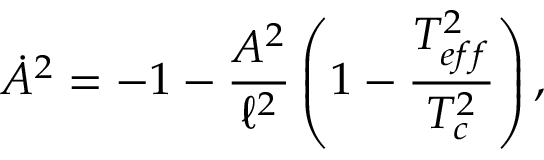<formula> <loc_0><loc_0><loc_500><loc_500>\dot { A } ^ { 2 } = - 1 - \frac { A ^ { 2 } } { \ell ^ { 2 } } \left ( 1 - \frac { T _ { e f f } ^ { 2 } } { T _ { c } ^ { 2 } } \right ) ,</formula> 